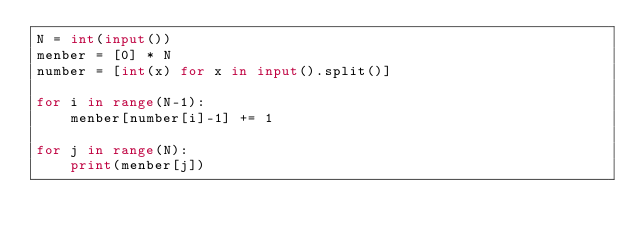Convert code to text. <code><loc_0><loc_0><loc_500><loc_500><_Python_>N = int(input())
menber = [0] * N
number = [int(x) for x in input().split()]

for i in range(N-1):
    menber[number[i]-1] += 1

for j in range(N):
    print(menber[j])</code> 